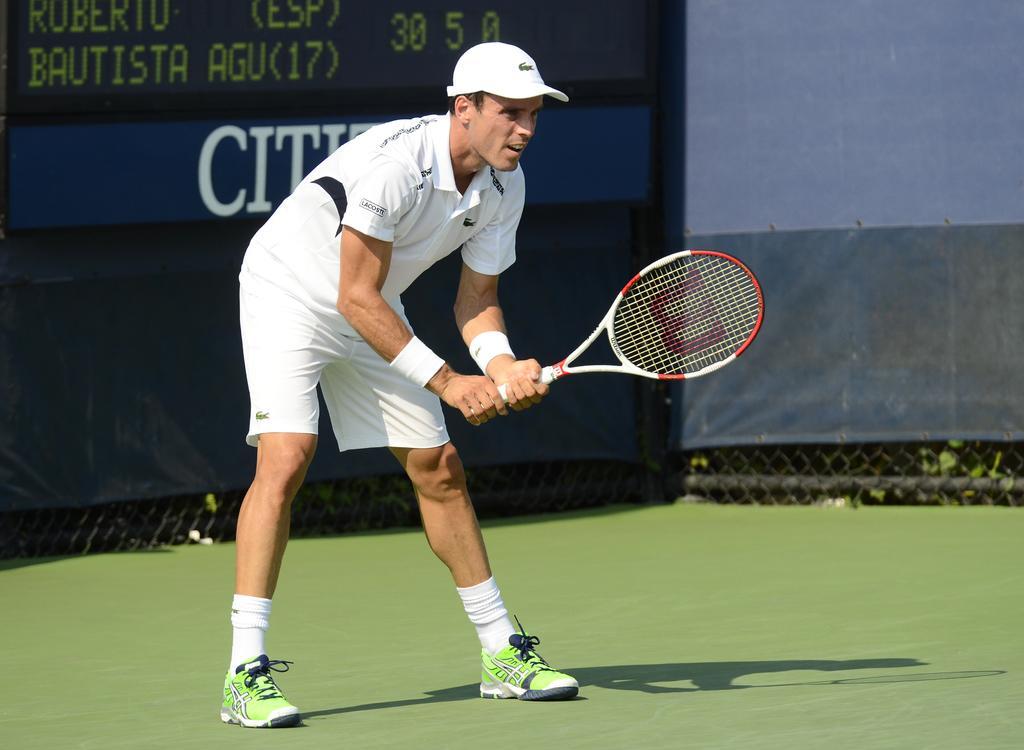Can you describe this image briefly? In this image I see a man who is standing on the ground and he is holding a bat, I can also see that he is wearing a white jersey and a cap on his head. In the background I see few words and numbers on this board. 